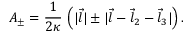<formula> <loc_0><loc_0><loc_500><loc_500>A _ { \pm } = { \frac { 1 } { 2 \kappa } } \, \left ( | \vec { l } | \pm | \vec { l } - \vec { l } _ { 2 } - \vec { l } _ { 3 } | \right ) .</formula> 